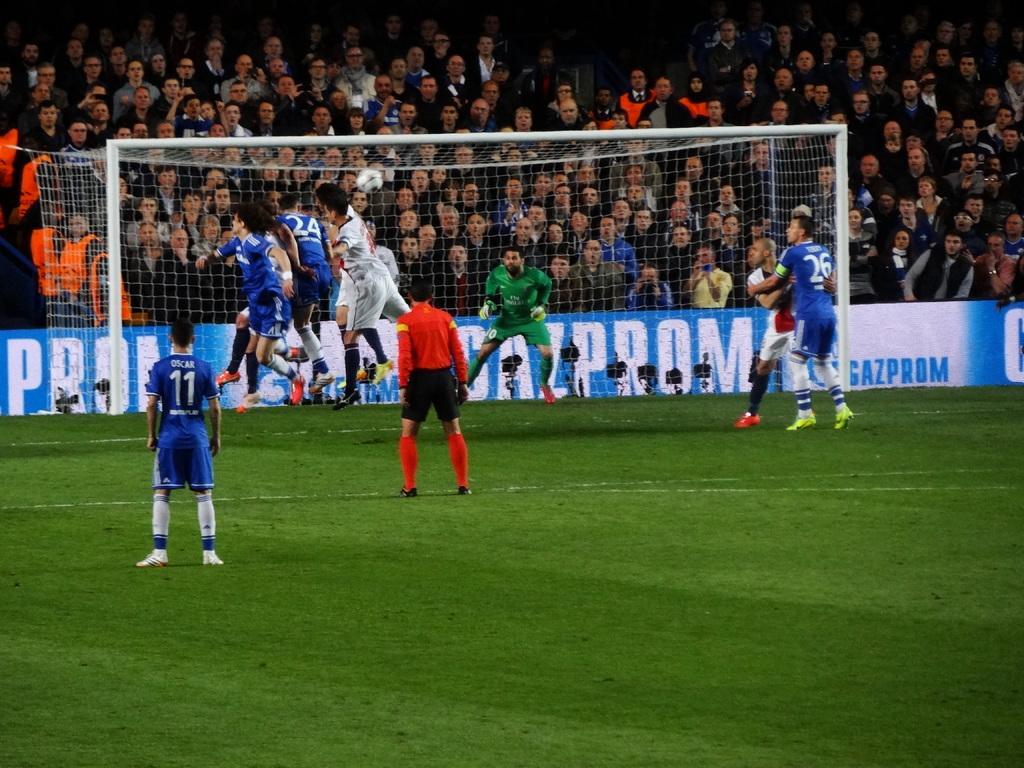Can you describe this image briefly? At the bottom of the image on the ground there is grass. And this is a food stadium. And there are few players on the ground. And also there is a goal. Behind them there is a banner with text on it. In the background there are many people. 